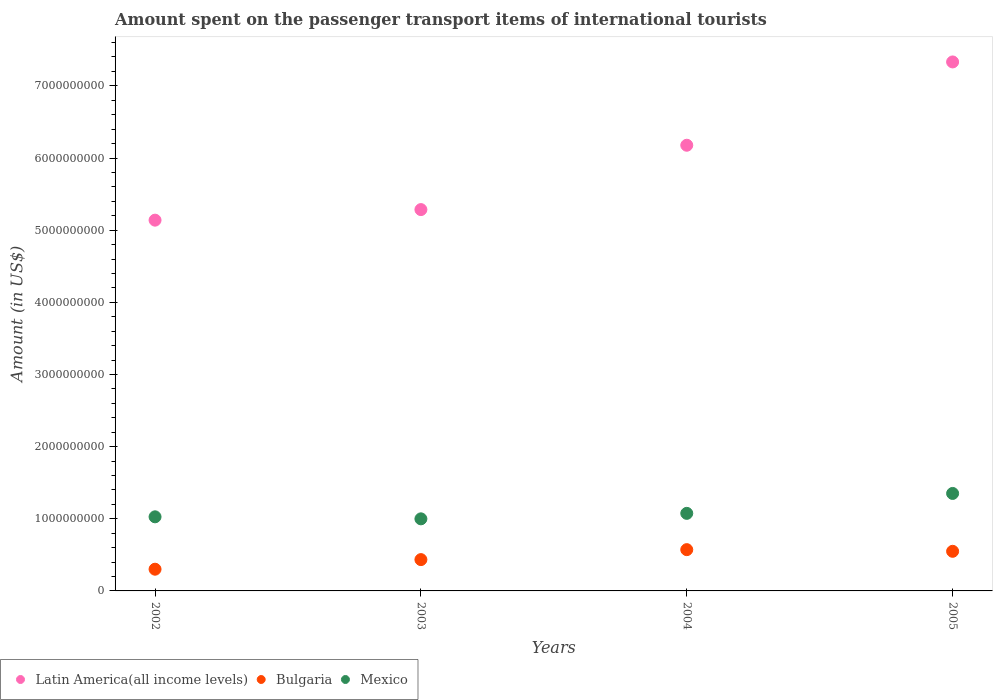What is the amount spent on the passenger transport items of international tourists in Latin America(all income levels) in 2005?
Offer a very short reply. 7.33e+09. Across all years, what is the maximum amount spent on the passenger transport items of international tourists in Latin America(all income levels)?
Offer a terse response. 7.33e+09. Across all years, what is the minimum amount spent on the passenger transport items of international tourists in Latin America(all income levels)?
Your answer should be very brief. 5.14e+09. In which year was the amount spent on the passenger transport items of international tourists in Latin America(all income levels) maximum?
Your response must be concise. 2005. In which year was the amount spent on the passenger transport items of international tourists in Latin America(all income levels) minimum?
Your response must be concise. 2002. What is the total amount spent on the passenger transport items of international tourists in Bulgaria in the graph?
Ensure brevity in your answer.  1.86e+09. What is the difference between the amount spent on the passenger transport items of international tourists in Mexico in 2003 and that in 2005?
Provide a succinct answer. -3.52e+08. What is the difference between the amount spent on the passenger transport items of international tourists in Bulgaria in 2004 and the amount spent on the passenger transport items of international tourists in Latin America(all income levels) in 2002?
Make the answer very short. -4.57e+09. What is the average amount spent on the passenger transport items of international tourists in Mexico per year?
Offer a terse response. 1.11e+09. In the year 2004, what is the difference between the amount spent on the passenger transport items of international tourists in Mexico and amount spent on the passenger transport items of international tourists in Latin America(all income levels)?
Provide a succinct answer. -5.10e+09. What is the ratio of the amount spent on the passenger transport items of international tourists in Mexico in 2004 to that in 2005?
Your answer should be very brief. 0.8. Is the amount spent on the passenger transport items of international tourists in Bulgaria in 2002 less than that in 2003?
Your response must be concise. Yes. Is the difference between the amount spent on the passenger transport items of international tourists in Mexico in 2002 and 2005 greater than the difference between the amount spent on the passenger transport items of international tourists in Latin America(all income levels) in 2002 and 2005?
Give a very brief answer. Yes. What is the difference between the highest and the second highest amount spent on the passenger transport items of international tourists in Bulgaria?
Make the answer very short. 2.30e+07. What is the difference between the highest and the lowest amount spent on the passenger transport items of international tourists in Bulgaria?
Your response must be concise. 2.71e+08. In how many years, is the amount spent on the passenger transport items of international tourists in Mexico greater than the average amount spent on the passenger transport items of international tourists in Mexico taken over all years?
Make the answer very short. 1. Is the sum of the amount spent on the passenger transport items of international tourists in Mexico in 2004 and 2005 greater than the maximum amount spent on the passenger transport items of international tourists in Latin America(all income levels) across all years?
Provide a short and direct response. No. Is the amount spent on the passenger transport items of international tourists in Bulgaria strictly greater than the amount spent on the passenger transport items of international tourists in Latin America(all income levels) over the years?
Offer a very short reply. No. Is the amount spent on the passenger transport items of international tourists in Bulgaria strictly less than the amount spent on the passenger transport items of international tourists in Mexico over the years?
Keep it short and to the point. Yes. What is the difference between two consecutive major ticks on the Y-axis?
Give a very brief answer. 1.00e+09. Are the values on the major ticks of Y-axis written in scientific E-notation?
Your answer should be very brief. No. Does the graph contain any zero values?
Your answer should be very brief. No. Does the graph contain grids?
Give a very brief answer. No. Where does the legend appear in the graph?
Your answer should be compact. Bottom left. How are the legend labels stacked?
Provide a succinct answer. Horizontal. What is the title of the graph?
Offer a very short reply. Amount spent on the passenger transport items of international tourists. What is the label or title of the X-axis?
Provide a short and direct response. Years. What is the label or title of the Y-axis?
Give a very brief answer. Amount (in US$). What is the Amount (in US$) in Latin America(all income levels) in 2002?
Your answer should be very brief. 5.14e+09. What is the Amount (in US$) in Bulgaria in 2002?
Offer a terse response. 3.01e+08. What is the Amount (in US$) of Mexico in 2002?
Your response must be concise. 1.03e+09. What is the Amount (in US$) of Latin America(all income levels) in 2003?
Your answer should be compact. 5.29e+09. What is the Amount (in US$) of Bulgaria in 2003?
Give a very brief answer. 4.34e+08. What is the Amount (in US$) of Mexico in 2003?
Your response must be concise. 9.99e+08. What is the Amount (in US$) of Latin America(all income levels) in 2004?
Your answer should be very brief. 6.18e+09. What is the Amount (in US$) of Bulgaria in 2004?
Give a very brief answer. 5.72e+08. What is the Amount (in US$) in Mexico in 2004?
Your answer should be compact. 1.08e+09. What is the Amount (in US$) in Latin America(all income levels) in 2005?
Offer a very short reply. 7.33e+09. What is the Amount (in US$) in Bulgaria in 2005?
Provide a short and direct response. 5.49e+08. What is the Amount (in US$) of Mexico in 2005?
Provide a succinct answer. 1.35e+09. Across all years, what is the maximum Amount (in US$) of Latin America(all income levels)?
Your answer should be compact. 7.33e+09. Across all years, what is the maximum Amount (in US$) in Bulgaria?
Provide a short and direct response. 5.72e+08. Across all years, what is the maximum Amount (in US$) of Mexico?
Ensure brevity in your answer.  1.35e+09. Across all years, what is the minimum Amount (in US$) of Latin America(all income levels)?
Offer a terse response. 5.14e+09. Across all years, what is the minimum Amount (in US$) of Bulgaria?
Offer a very short reply. 3.01e+08. Across all years, what is the minimum Amount (in US$) in Mexico?
Provide a short and direct response. 9.99e+08. What is the total Amount (in US$) of Latin America(all income levels) in the graph?
Ensure brevity in your answer.  2.39e+1. What is the total Amount (in US$) of Bulgaria in the graph?
Your answer should be very brief. 1.86e+09. What is the total Amount (in US$) in Mexico in the graph?
Your answer should be compact. 4.45e+09. What is the difference between the Amount (in US$) in Latin America(all income levels) in 2002 and that in 2003?
Provide a short and direct response. -1.46e+08. What is the difference between the Amount (in US$) in Bulgaria in 2002 and that in 2003?
Provide a short and direct response. -1.33e+08. What is the difference between the Amount (in US$) of Mexico in 2002 and that in 2003?
Ensure brevity in your answer.  2.80e+07. What is the difference between the Amount (in US$) in Latin America(all income levels) in 2002 and that in 2004?
Provide a succinct answer. -1.04e+09. What is the difference between the Amount (in US$) in Bulgaria in 2002 and that in 2004?
Your answer should be very brief. -2.71e+08. What is the difference between the Amount (in US$) in Mexico in 2002 and that in 2004?
Offer a terse response. -4.80e+07. What is the difference between the Amount (in US$) in Latin America(all income levels) in 2002 and that in 2005?
Provide a succinct answer. -2.19e+09. What is the difference between the Amount (in US$) in Bulgaria in 2002 and that in 2005?
Give a very brief answer. -2.48e+08. What is the difference between the Amount (in US$) in Mexico in 2002 and that in 2005?
Your response must be concise. -3.24e+08. What is the difference between the Amount (in US$) in Latin America(all income levels) in 2003 and that in 2004?
Offer a terse response. -8.92e+08. What is the difference between the Amount (in US$) in Bulgaria in 2003 and that in 2004?
Your response must be concise. -1.38e+08. What is the difference between the Amount (in US$) in Mexico in 2003 and that in 2004?
Your response must be concise. -7.60e+07. What is the difference between the Amount (in US$) in Latin America(all income levels) in 2003 and that in 2005?
Offer a terse response. -2.05e+09. What is the difference between the Amount (in US$) in Bulgaria in 2003 and that in 2005?
Ensure brevity in your answer.  -1.15e+08. What is the difference between the Amount (in US$) in Mexico in 2003 and that in 2005?
Offer a terse response. -3.52e+08. What is the difference between the Amount (in US$) of Latin America(all income levels) in 2004 and that in 2005?
Make the answer very short. -1.15e+09. What is the difference between the Amount (in US$) in Bulgaria in 2004 and that in 2005?
Your answer should be very brief. 2.30e+07. What is the difference between the Amount (in US$) of Mexico in 2004 and that in 2005?
Provide a short and direct response. -2.76e+08. What is the difference between the Amount (in US$) in Latin America(all income levels) in 2002 and the Amount (in US$) in Bulgaria in 2003?
Offer a very short reply. 4.70e+09. What is the difference between the Amount (in US$) of Latin America(all income levels) in 2002 and the Amount (in US$) of Mexico in 2003?
Give a very brief answer. 4.14e+09. What is the difference between the Amount (in US$) in Bulgaria in 2002 and the Amount (in US$) in Mexico in 2003?
Make the answer very short. -6.98e+08. What is the difference between the Amount (in US$) of Latin America(all income levels) in 2002 and the Amount (in US$) of Bulgaria in 2004?
Make the answer very short. 4.57e+09. What is the difference between the Amount (in US$) of Latin America(all income levels) in 2002 and the Amount (in US$) of Mexico in 2004?
Make the answer very short. 4.06e+09. What is the difference between the Amount (in US$) of Bulgaria in 2002 and the Amount (in US$) of Mexico in 2004?
Your answer should be very brief. -7.74e+08. What is the difference between the Amount (in US$) in Latin America(all income levels) in 2002 and the Amount (in US$) in Bulgaria in 2005?
Offer a terse response. 4.59e+09. What is the difference between the Amount (in US$) in Latin America(all income levels) in 2002 and the Amount (in US$) in Mexico in 2005?
Your response must be concise. 3.79e+09. What is the difference between the Amount (in US$) of Bulgaria in 2002 and the Amount (in US$) of Mexico in 2005?
Keep it short and to the point. -1.05e+09. What is the difference between the Amount (in US$) of Latin America(all income levels) in 2003 and the Amount (in US$) of Bulgaria in 2004?
Your response must be concise. 4.71e+09. What is the difference between the Amount (in US$) in Latin America(all income levels) in 2003 and the Amount (in US$) in Mexico in 2004?
Give a very brief answer. 4.21e+09. What is the difference between the Amount (in US$) in Bulgaria in 2003 and the Amount (in US$) in Mexico in 2004?
Offer a terse response. -6.41e+08. What is the difference between the Amount (in US$) of Latin America(all income levels) in 2003 and the Amount (in US$) of Bulgaria in 2005?
Your answer should be compact. 4.74e+09. What is the difference between the Amount (in US$) in Latin America(all income levels) in 2003 and the Amount (in US$) in Mexico in 2005?
Make the answer very short. 3.93e+09. What is the difference between the Amount (in US$) in Bulgaria in 2003 and the Amount (in US$) in Mexico in 2005?
Give a very brief answer. -9.17e+08. What is the difference between the Amount (in US$) of Latin America(all income levels) in 2004 and the Amount (in US$) of Bulgaria in 2005?
Ensure brevity in your answer.  5.63e+09. What is the difference between the Amount (in US$) of Latin America(all income levels) in 2004 and the Amount (in US$) of Mexico in 2005?
Your response must be concise. 4.83e+09. What is the difference between the Amount (in US$) in Bulgaria in 2004 and the Amount (in US$) in Mexico in 2005?
Make the answer very short. -7.79e+08. What is the average Amount (in US$) of Latin America(all income levels) per year?
Provide a succinct answer. 5.98e+09. What is the average Amount (in US$) of Bulgaria per year?
Keep it short and to the point. 4.64e+08. What is the average Amount (in US$) of Mexico per year?
Your answer should be very brief. 1.11e+09. In the year 2002, what is the difference between the Amount (in US$) of Latin America(all income levels) and Amount (in US$) of Bulgaria?
Your response must be concise. 4.84e+09. In the year 2002, what is the difference between the Amount (in US$) in Latin America(all income levels) and Amount (in US$) in Mexico?
Offer a terse response. 4.11e+09. In the year 2002, what is the difference between the Amount (in US$) in Bulgaria and Amount (in US$) in Mexico?
Offer a terse response. -7.26e+08. In the year 2003, what is the difference between the Amount (in US$) in Latin America(all income levels) and Amount (in US$) in Bulgaria?
Give a very brief answer. 4.85e+09. In the year 2003, what is the difference between the Amount (in US$) of Latin America(all income levels) and Amount (in US$) of Mexico?
Provide a short and direct response. 4.29e+09. In the year 2003, what is the difference between the Amount (in US$) in Bulgaria and Amount (in US$) in Mexico?
Make the answer very short. -5.65e+08. In the year 2004, what is the difference between the Amount (in US$) in Latin America(all income levels) and Amount (in US$) in Bulgaria?
Offer a terse response. 5.60e+09. In the year 2004, what is the difference between the Amount (in US$) of Latin America(all income levels) and Amount (in US$) of Mexico?
Your answer should be compact. 5.10e+09. In the year 2004, what is the difference between the Amount (in US$) in Bulgaria and Amount (in US$) in Mexico?
Give a very brief answer. -5.03e+08. In the year 2005, what is the difference between the Amount (in US$) in Latin America(all income levels) and Amount (in US$) in Bulgaria?
Give a very brief answer. 6.78e+09. In the year 2005, what is the difference between the Amount (in US$) of Latin America(all income levels) and Amount (in US$) of Mexico?
Keep it short and to the point. 5.98e+09. In the year 2005, what is the difference between the Amount (in US$) in Bulgaria and Amount (in US$) in Mexico?
Offer a terse response. -8.02e+08. What is the ratio of the Amount (in US$) of Latin America(all income levels) in 2002 to that in 2003?
Offer a terse response. 0.97. What is the ratio of the Amount (in US$) of Bulgaria in 2002 to that in 2003?
Offer a terse response. 0.69. What is the ratio of the Amount (in US$) of Mexico in 2002 to that in 2003?
Offer a terse response. 1.03. What is the ratio of the Amount (in US$) of Latin America(all income levels) in 2002 to that in 2004?
Provide a succinct answer. 0.83. What is the ratio of the Amount (in US$) of Bulgaria in 2002 to that in 2004?
Your answer should be compact. 0.53. What is the ratio of the Amount (in US$) in Mexico in 2002 to that in 2004?
Keep it short and to the point. 0.96. What is the ratio of the Amount (in US$) of Latin America(all income levels) in 2002 to that in 2005?
Make the answer very short. 0.7. What is the ratio of the Amount (in US$) of Bulgaria in 2002 to that in 2005?
Ensure brevity in your answer.  0.55. What is the ratio of the Amount (in US$) in Mexico in 2002 to that in 2005?
Your answer should be very brief. 0.76. What is the ratio of the Amount (in US$) of Latin America(all income levels) in 2003 to that in 2004?
Your answer should be very brief. 0.86. What is the ratio of the Amount (in US$) in Bulgaria in 2003 to that in 2004?
Offer a very short reply. 0.76. What is the ratio of the Amount (in US$) of Mexico in 2003 to that in 2004?
Your response must be concise. 0.93. What is the ratio of the Amount (in US$) of Latin America(all income levels) in 2003 to that in 2005?
Ensure brevity in your answer.  0.72. What is the ratio of the Amount (in US$) of Bulgaria in 2003 to that in 2005?
Your answer should be very brief. 0.79. What is the ratio of the Amount (in US$) in Mexico in 2003 to that in 2005?
Make the answer very short. 0.74. What is the ratio of the Amount (in US$) of Latin America(all income levels) in 2004 to that in 2005?
Offer a very short reply. 0.84. What is the ratio of the Amount (in US$) of Bulgaria in 2004 to that in 2005?
Make the answer very short. 1.04. What is the ratio of the Amount (in US$) in Mexico in 2004 to that in 2005?
Your response must be concise. 0.8. What is the difference between the highest and the second highest Amount (in US$) of Latin America(all income levels)?
Your answer should be very brief. 1.15e+09. What is the difference between the highest and the second highest Amount (in US$) in Bulgaria?
Ensure brevity in your answer.  2.30e+07. What is the difference between the highest and the second highest Amount (in US$) in Mexico?
Provide a short and direct response. 2.76e+08. What is the difference between the highest and the lowest Amount (in US$) in Latin America(all income levels)?
Give a very brief answer. 2.19e+09. What is the difference between the highest and the lowest Amount (in US$) of Bulgaria?
Your answer should be very brief. 2.71e+08. What is the difference between the highest and the lowest Amount (in US$) in Mexico?
Offer a very short reply. 3.52e+08. 